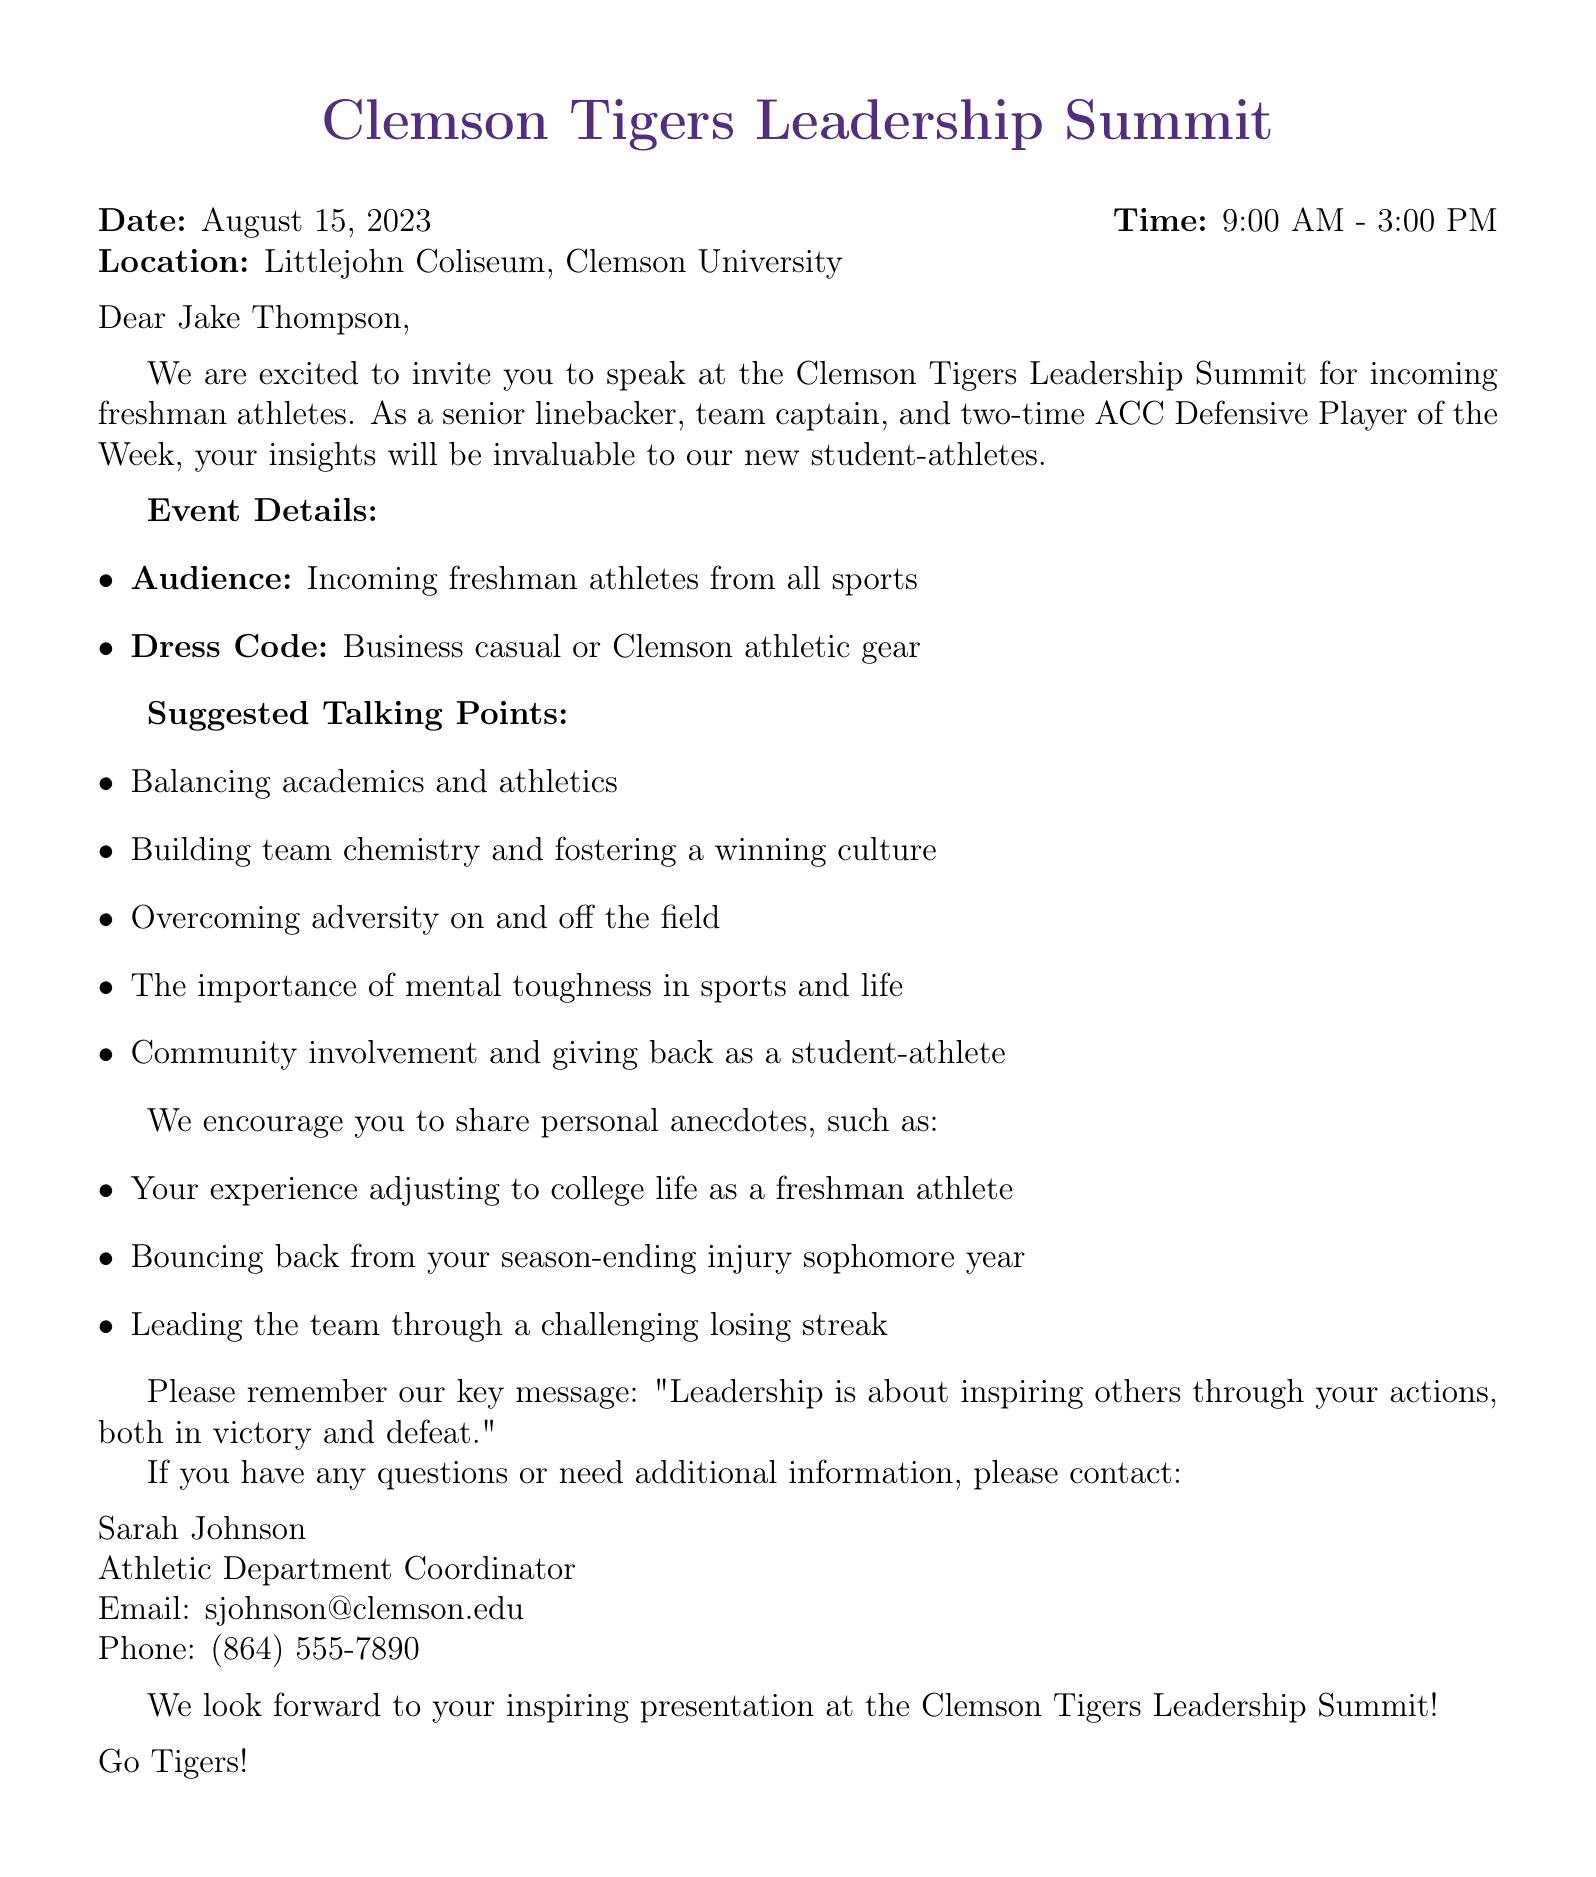What is the name of the event? The name of the event is stated in the document as the "Clemson Tigers Leadership Summit."
Answer: Clemson Tigers Leadership Summit When is the event scheduled to take place? The document specifies that the event date is August 15, 2023.
Answer: August 15, 2023 Who is the speaker for the event? The speaker's name is mentioned in the document as Jake Thompson.
Answer: Jake Thompson What is the dress code for the seminar? The document lists the dress code as "Business casual or Clemson athletic gear."
Answer: Business casual or Clemson athletic gear What are the first two talking points provided? The document specifies the first two talking points as "Balancing academics and athletics" and "Building team chemistry and fostering a winning culture."
Answer: Balancing academics and athletics; Building team chemistry and fostering a winning culture What personal anecdote is suggested about adjusting to college life? The document suggests sharing the personal anecdote about "Adjusting to college life as a freshman athlete."
Answer: Adjusting to college life as a freshman athlete What is the key message of the event? The document states the key message as "Leadership is about inspiring others through your actions, both in victory and defeat."
Answer: Leadership is about inspiring others through your actions, both in victory and defeat Who should be contacted for more information? The document designates Sarah Johnson as the contact person for more information.
Answer: Sarah Johnson What time does the event start? The event time is clearly stated in the document as "9:00 AM."
Answer: 9:00 AM 